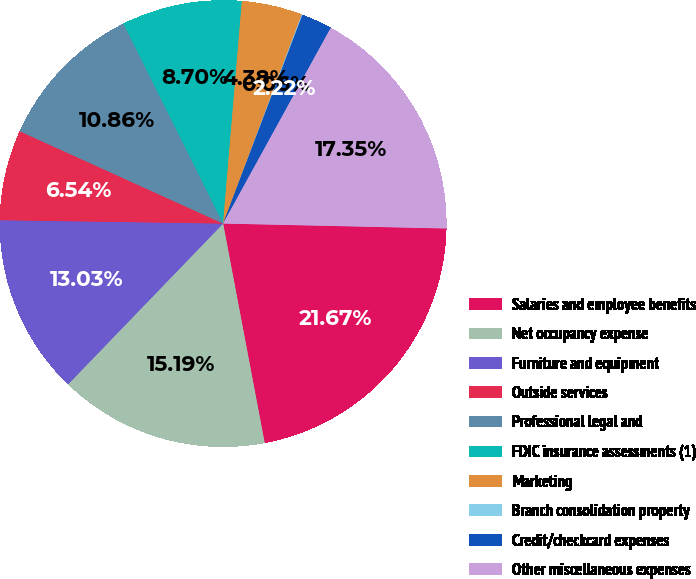Convert chart. <chart><loc_0><loc_0><loc_500><loc_500><pie_chart><fcel>Salaries and employee benefits<fcel>Net occupancy expense<fcel>Furniture and equipment<fcel>Outside services<fcel>Professional legal and<fcel>FDIC insurance assessments (1)<fcel>Marketing<fcel>Branch consolidation property<fcel>Credit/checkcard expenses<fcel>Other miscellaneous expenses<nl><fcel>21.67%<fcel>15.19%<fcel>13.03%<fcel>6.54%<fcel>10.86%<fcel>8.7%<fcel>4.38%<fcel>0.06%<fcel>2.22%<fcel>17.35%<nl></chart> 